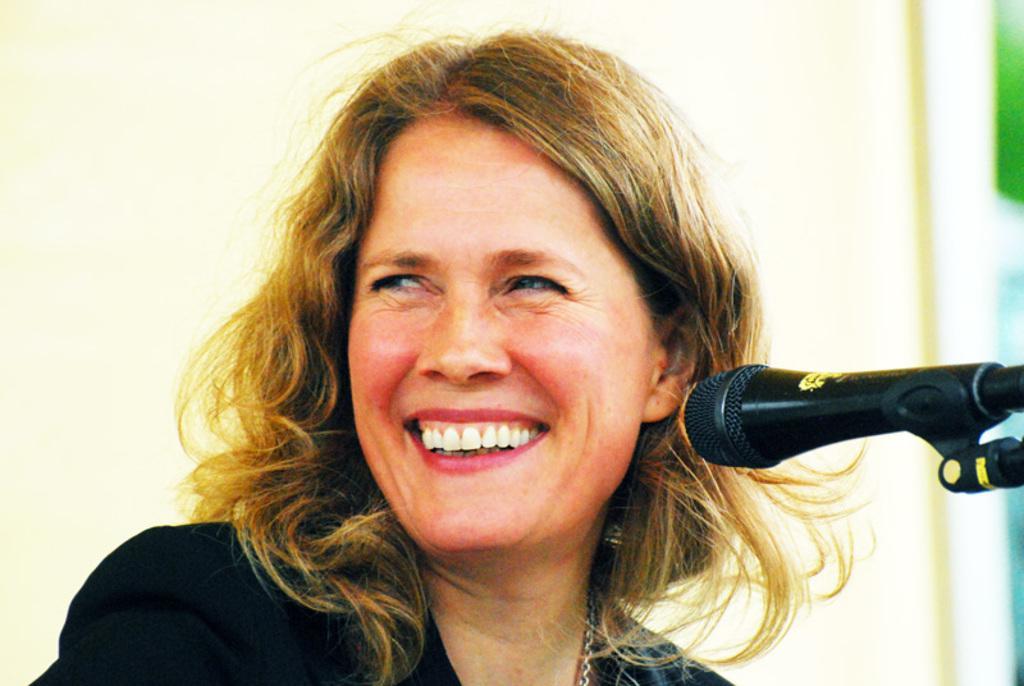Can you describe this image briefly? In the middle of the image there is a microphone and a woman is smiling. Behind her there is a wall. 